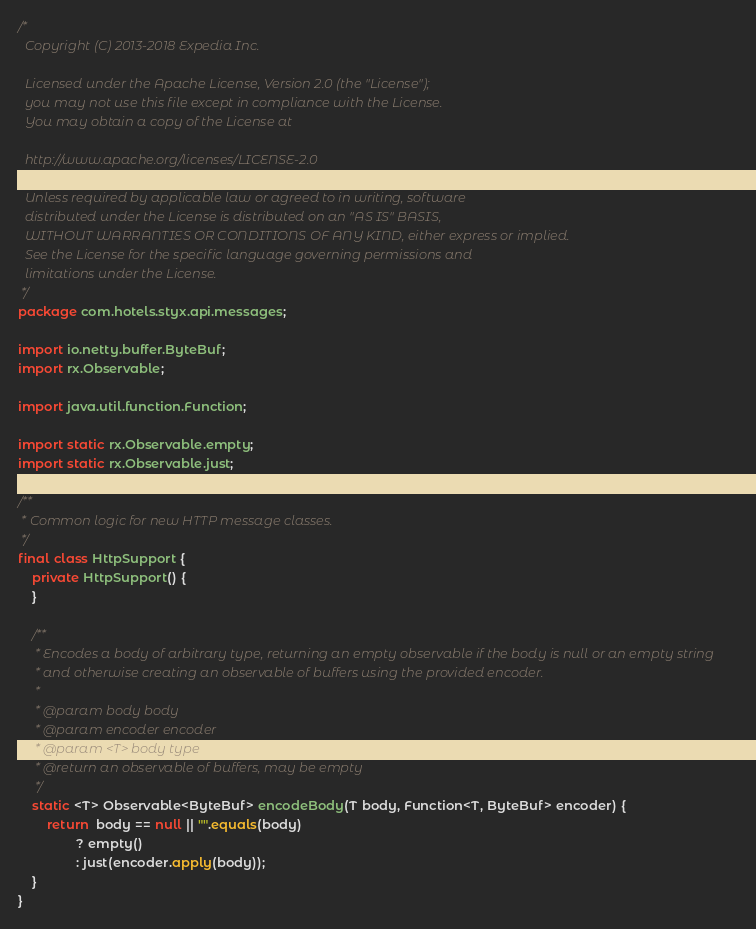Convert code to text. <code><loc_0><loc_0><loc_500><loc_500><_Java_>/*
  Copyright (C) 2013-2018 Expedia Inc.

  Licensed under the Apache License, Version 2.0 (the "License");
  you may not use this file except in compliance with the License.
  You may obtain a copy of the License at

  http://www.apache.org/licenses/LICENSE-2.0

  Unless required by applicable law or agreed to in writing, software
  distributed under the License is distributed on an "AS IS" BASIS,
  WITHOUT WARRANTIES OR CONDITIONS OF ANY KIND, either express or implied.
  See the License for the specific language governing permissions and
  limitations under the License.
 */
package com.hotels.styx.api.messages;

import io.netty.buffer.ByteBuf;
import rx.Observable;

import java.util.function.Function;

import static rx.Observable.empty;
import static rx.Observable.just;

/**
 * Common logic for new HTTP message classes.
 */
final class HttpSupport {
    private HttpSupport() {
    }

    /**
     * Encodes a body of arbitrary type, returning an empty observable if the body is null or an empty string
     * and otherwise creating an observable of buffers using the provided encoder.
     *
     * @param body body
     * @param encoder encoder
     * @param <T> body type
     * @return an observable of buffers, may be empty
     */
    static <T> Observable<ByteBuf> encodeBody(T body, Function<T, ByteBuf> encoder) {
        return  body == null || "".equals(body)
                ? empty()
                : just(encoder.apply(body));
    }
}
</code> 